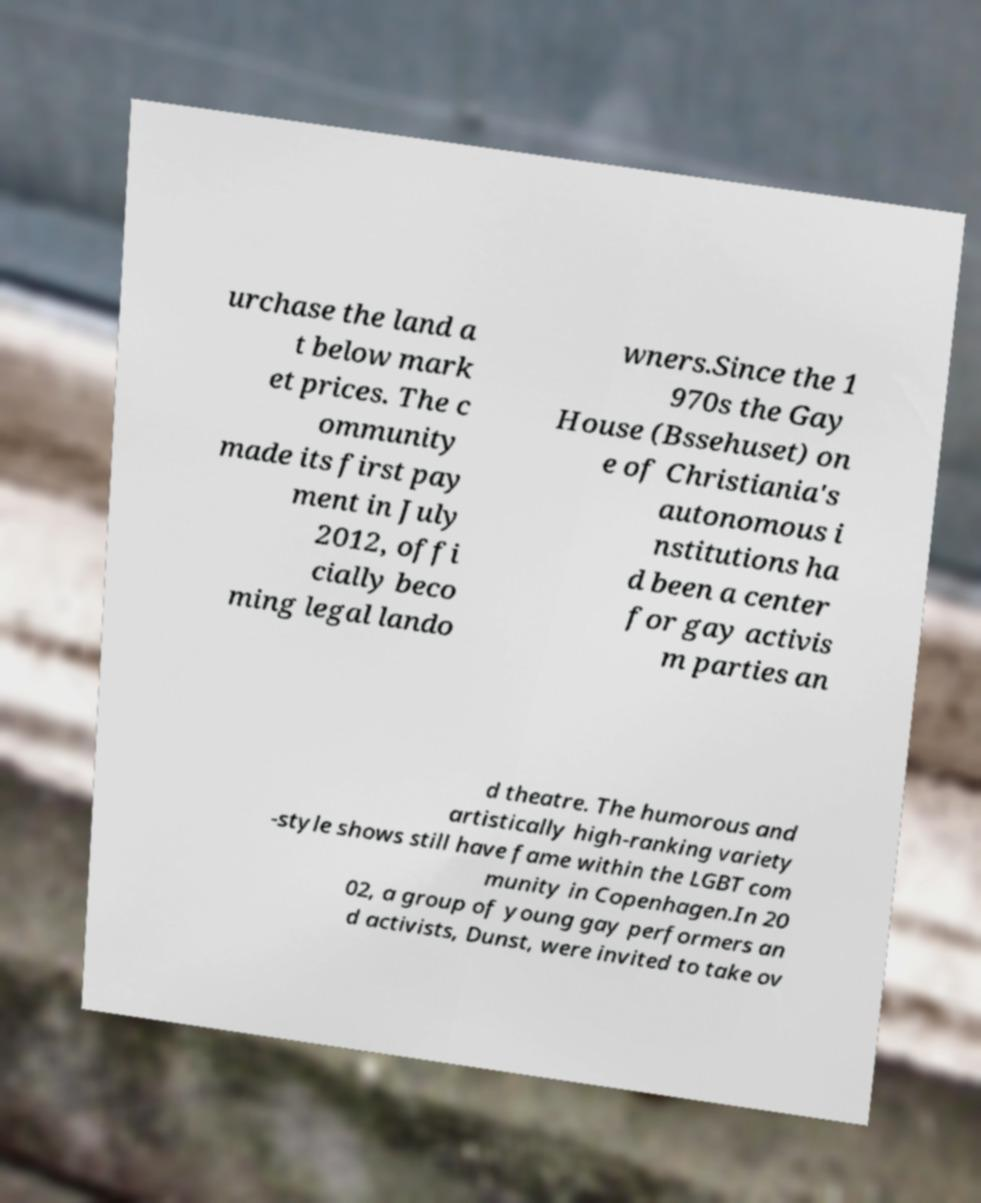Can you accurately transcribe the text from the provided image for me? urchase the land a t below mark et prices. The c ommunity made its first pay ment in July 2012, offi cially beco ming legal lando wners.Since the 1 970s the Gay House (Bssehuset) on e of Christiania's autonomous i nstitutions ha d been a center for gay activis m parties an d theatre. The humorous and artistically high-ranking variety -style shows still have fame within the LGBT com munity in Copenhagen.In 20 02, a group of young gay performers an d activists, Dunst, were invited to take ov 